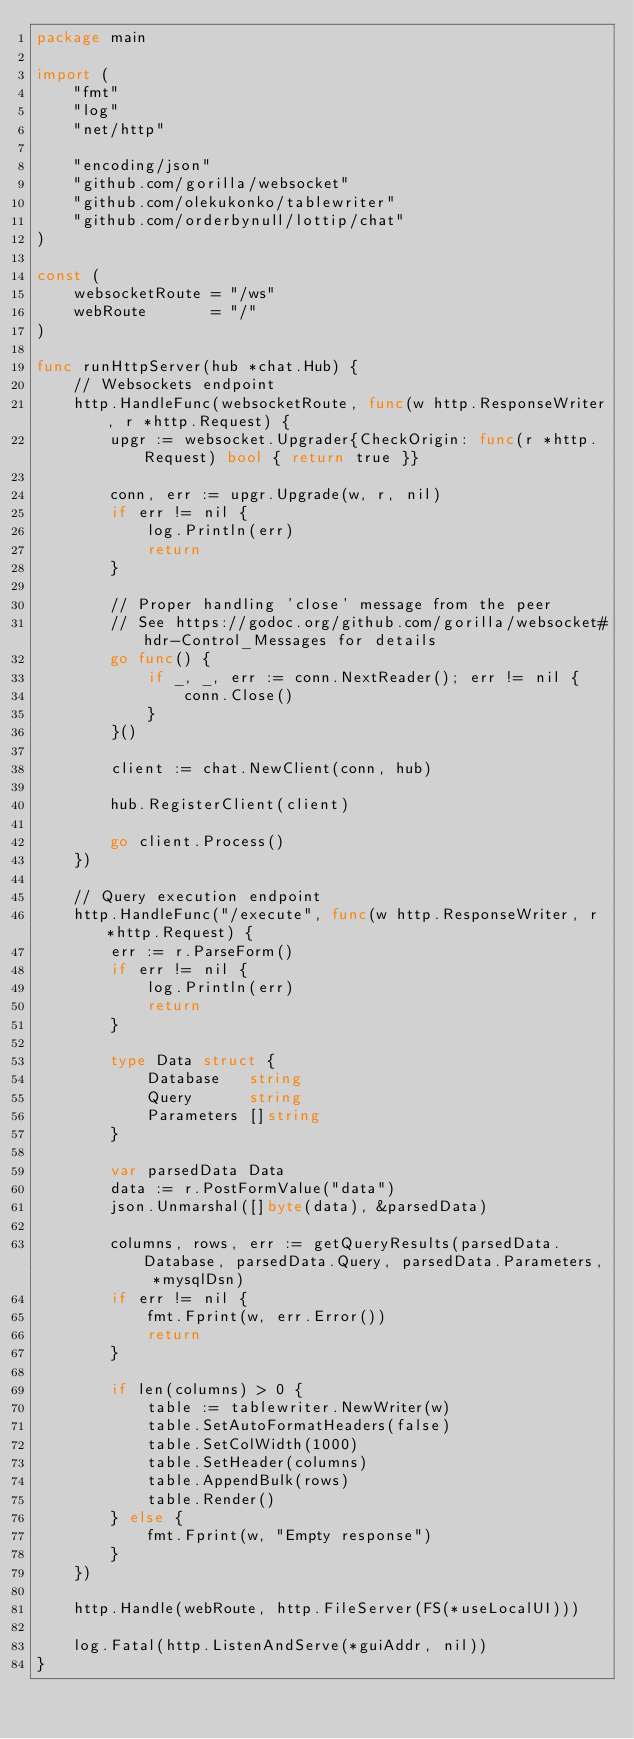<code> <loc_0><loc_0><loc_500><loc_500><_Go_>package main

import (
	"fmt"
	"log"
	"net/http"

	"encoding/json"
	"github.com/gorilla/websocket"
	"github.com/olekukonko/tablewriter"
	"github.com/orderbynull/lottip/chat"
)

const (
	websocketRoute = "/ws"
	webRoute       = "/"
)

func runHttpServer(hub *chat.Hub) {
	// Websockets endpoint
	http.HandleFunc(websocketRoute, func(w http.ResponseWriter, r *http.Request) {
		upgr := websocket.Upgrader{CheckOrigin: func(r *http.Request) bool { return true }}

		conn, err := upgr.Upgrade(w, r, nil)
		if err != nil {
			log.Println(err)
			return
		}

		// Proper handling 'close' message from the peer
		// See https://godoc.org/github.com/gorilla/websocket#hdr-Control_Messages for details
		go func() {
			if _, _, err := conn.NextReader(); err != nil {
				conn.Close()
			}
		}()

		client := chat.NewClient(conn, hub)

		hub.RegisterClient(client)

		go client.Process()
	})

	// Query execution endpoint
	http.HandleFunc("/execute", func(w http.ResponseWriter, r *http.Request) {
		err := r.ParseForm()
		if err != nil {
			log.Println(err)
			return
		}

		type Data struct {
			Database   string
			Query      string
			Parameters []string
		}

		var parsedData Data
		data := r.PostFormValue("data")
		json.Unmarshal([]byte(data), &parsedData)

		columns, rows, err := getQueryResults(parsedData.Database, parsedData.Query, parsedData.Parameters, *mysqlDsn)
		if err != nil {
			fmt.Fprint(w, err.Error())
			return
		}

		if len(columns) > 0 {
			table := tablewriter.NewWriter(w)
			table.SetAutoFormatHeaders(false)
			table.SetColWidth(1000)
			table.SetHeader(columns)
			table.AppendBulk(rows)
			table.Render()
		} else {
			fmt.Fprint(w, "Empty response")
		}
	})

	http.Handle(webRoute, http.FileServer(FS(*useLocalUI)))

	log.Fatal(http.ListenAndServe(*guiAddr, nil))
}
</code> 